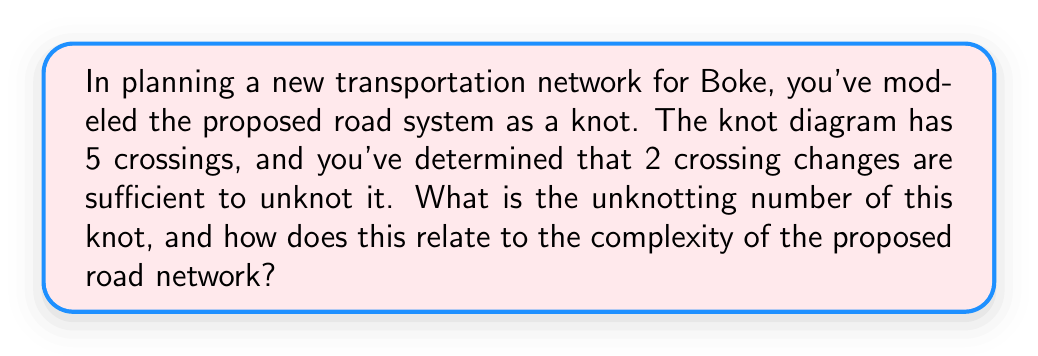Show me your answer to this math problem. To solve this problem, we need to understand the concept of unknotting number and its relevance to transportation networks:

1. Unknotting number definition:
   The unknotting number $u(K)$ of a knot $K$ is the minimum number of crossing changes required to transform the knot into the unknot (trivial knot).

2. Given information:
   - The knot has 5 crossings in its diagram.
   - 2 crossing changes are sufficient to unknot it.

3. Determining the unknotting number:
   Since 2 crossing changes are sufficient to unknot the knot, and this is the minimum number given, we can conclude that the unknotting number $u(K) = 2$.

4. Relation to transportation network complexity:
   The unknotting number can be interpreted as a measure of the network's complexity:
   - A higher unknotting number indicates a more complex network structure.
   - A lower unknotting number suggests a simpler, more straightforward network layout.

5. Interpretation for Boke's road system:
   With an unknotting number of 2, the proposed road network has moderate complexity:
   - It's not trivial (which would have $u(K) = 0$).
   - It's not extremely complex (which would have a higher unknotting number).
   - The network requires some strategic modifications (corresponding to the 2 crossing changes) to simplify its structure.

This analysis suggests that the proposed transportation network for Boke has a balanced level of complexity, potentially offering good connectivity while not being overly convoluted.
Answer: $u(K) = 2$; moderate network complexity 